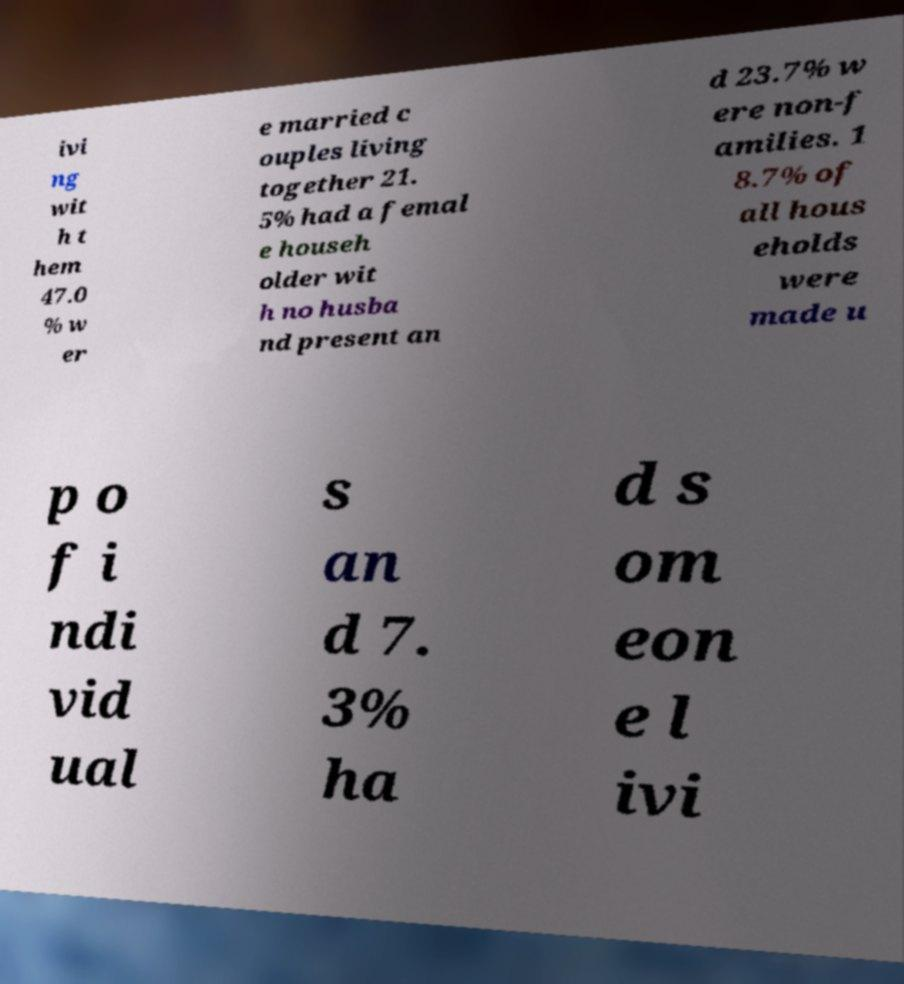Can you read and provide the text displayed in the image?This photo seems to have some interesting text. Can you extract and type it out for me? ivi ng wit h t hem 47.0 % w er e married c ouples living together 21. 5% had a femal e househ older wit h no husba nd present an d 23.7% w ere non-f amilies. 1 8.7% of all hous eholds were made u p o f i ndi vid ual s an d 7. 3% ha d s om eon e l ivi 